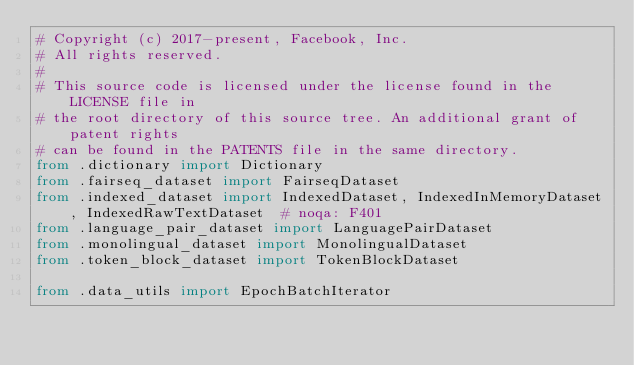Convert code to text. <code><loc_0><loc_0><loc_500><loc_500><_Python_># Copyright (c) 2017-present, Facebook, Inc.
# All rights reserved.
#
# This source code is licensed under the license found in the LICENSE file in
# the root directory of this source tree. An additional grant of patent rights
# can be found in the PATENTS file in the same directory.
from .dictionary import Dictionary
from .fairseq_dataset import FairseqDataset
from .indexed_dataset import IndexedDataset, IndexedInMemoryDataset, IndexedRawTextDataset  # noqa: F401
from .language_pair_dataset import LanguagePairDataset
from .monolingual_dataset import MonolingualDataset
from .token_block_dataset import TokenBlockDataset

from .data_utils import EpochBatchIterator
</code> 